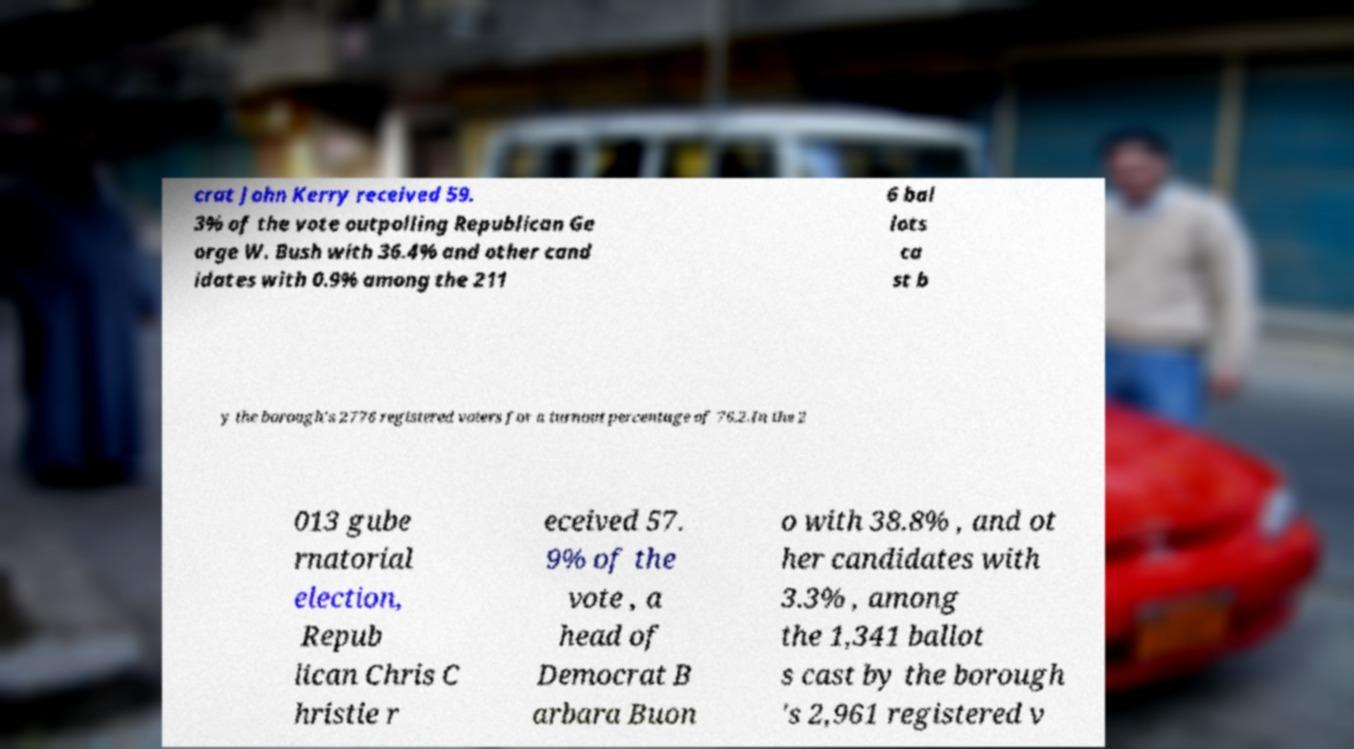Could you assist in decoding the text presented in this image and type it out clearly? crat John Kerry received 59. 3% of the vote outpolling Republican Ge orge W. Bush with 36.4% and other cand idates with 0.9% among the 211 6 bal lots ca st b y the borough's 2776 registered voters for a turnout percentage of 76.2.In the 2 013 gube rnatorial election, Repub lican Chris C hristie r eceived 57. 9% of the vote , a head of Democrat B arbara Buon o with 38.8% , and ot her candidates with 3.3% , among the 1,341 ballot s cast by the borough 's 2,961 registered v 